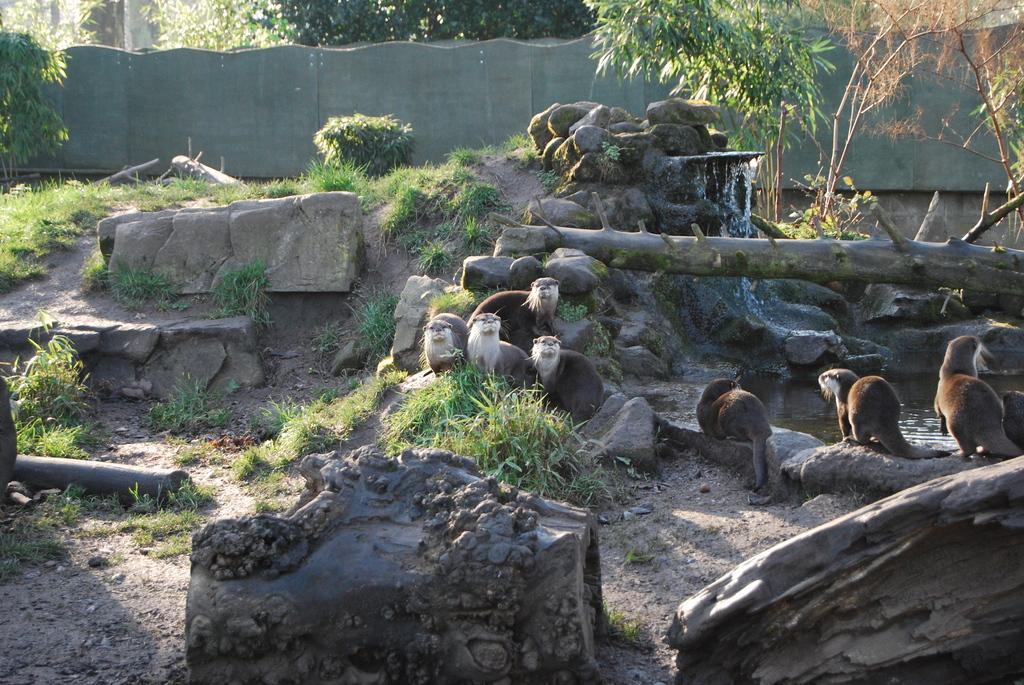Could you give a brief overview of what you see in this image? In this image we can see animals sitting and standing on the rocks, shrubs, ground, wall and trees. 